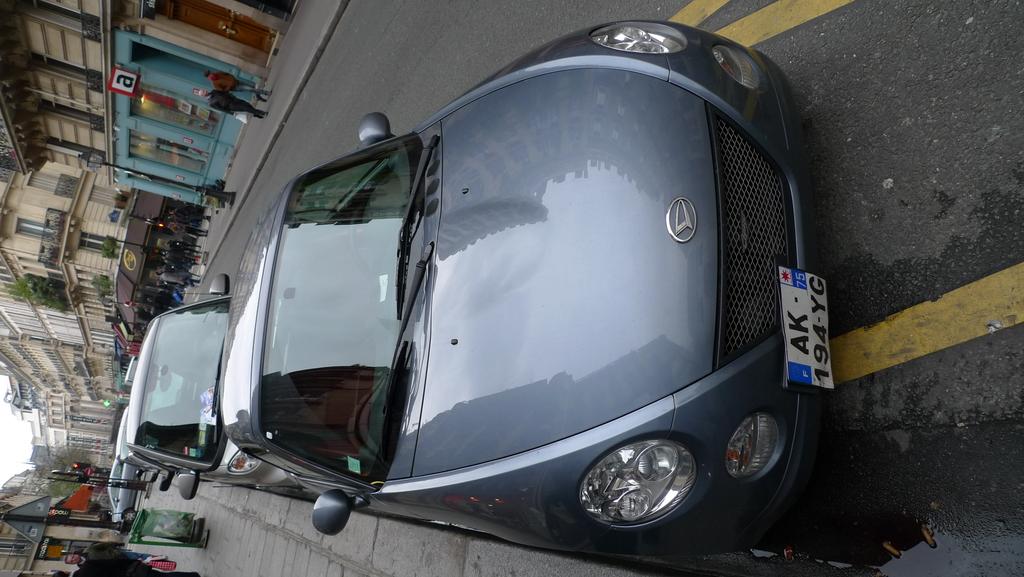Is that an "a" on the sign in the back?
Your answer should be compact. Yes. What is the incense plate number of the car?
Offer a very short reply. Ak 194 yg. 